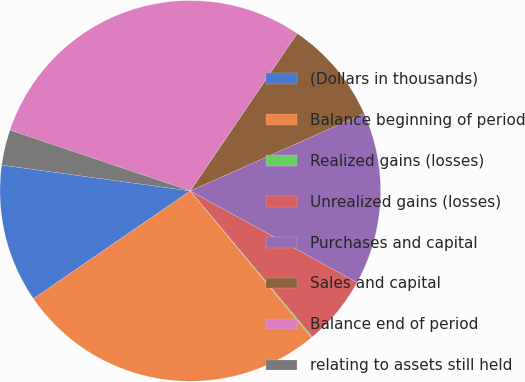Convert chart. <chart><loc_0><loc_0><loc_500><loc_500><pie_chart><fcel>(Dollars in thousands)<fcel>Balance beginning of period<fcel>Realized gains (losses)<fcel>Unrealized gains (losses)<fcel>Purchases and capital<fcel>Sales and capital<fcel>Balance end of period<fcel>relating to assets still held<nl><fcel>11.75%<fcel>26.4%<fcel>0.1%<fcel>5.92%<fcel>14.66%<fcel>8.84%<fcel>29.31%<fcel>3.01%<nl></chart> 